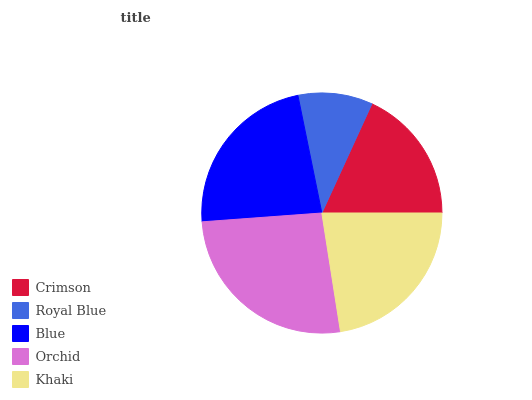Is Royal Blue the minimum?
Answer yes or no. Yes. Is Orchid the maximum?
Answer yes or no. Yes. Is Blue the minimum?
Answer yes or no. No. Is Blue the maximum?
Answer yes or no. No. Is Blue greater than Royal Blue?
Answer yes or no. Yes. Is Royal Blue less than Blue?
Answer yes or no. Yes. Is Royal Blue greater than Blue?
Answer yes or no. No. Is Blue less than Royal Blue?
Answer yes or no. No. Is Khaki the high median?
Answer yes or no. Yes. Is Khaki the low median?
Answer yes or no. Yes. Is Crimson the high median?
Answer yes or no. No. Is Blue the low median?
Answer yes or no. No. 